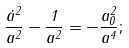Convert formula to latex. <formula><loc_0><loc_0><loc_500><loc_500>\frac { \dot { a } ^ { 2 } } { a ^ { 2 } } - \frac { 1 } { a ^ { 2 } } = - \frac { a _ { 0 } ^ { 2 } } { a ^ { 4 } } ;</formula> 